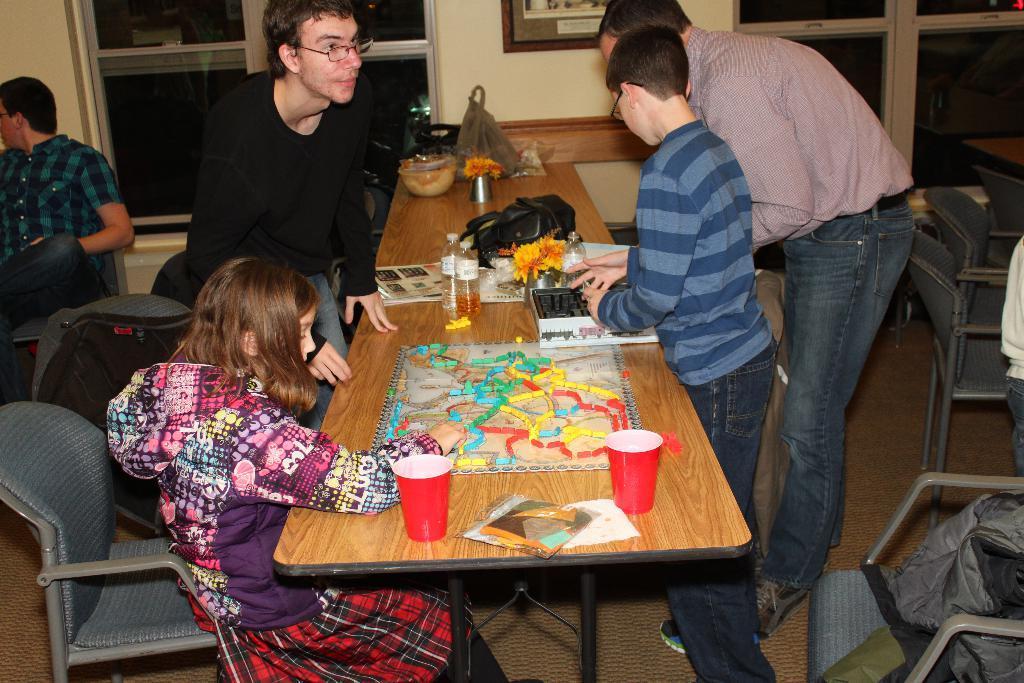Could you give a brief overview of what you see in this image? This a picture with group of persons there are three men and two children, the two children were playing a game the other man helping the kid how to play the game and the other man how is siting on a chair, the table were made with wooden on the top the table there is a toy, and two bottles, and two cups and there is bag on the table also and the bowl. The man in black t shirt having a spectacles, backside of the person there is glass window and the wall in cream color on the floor there is mat. 